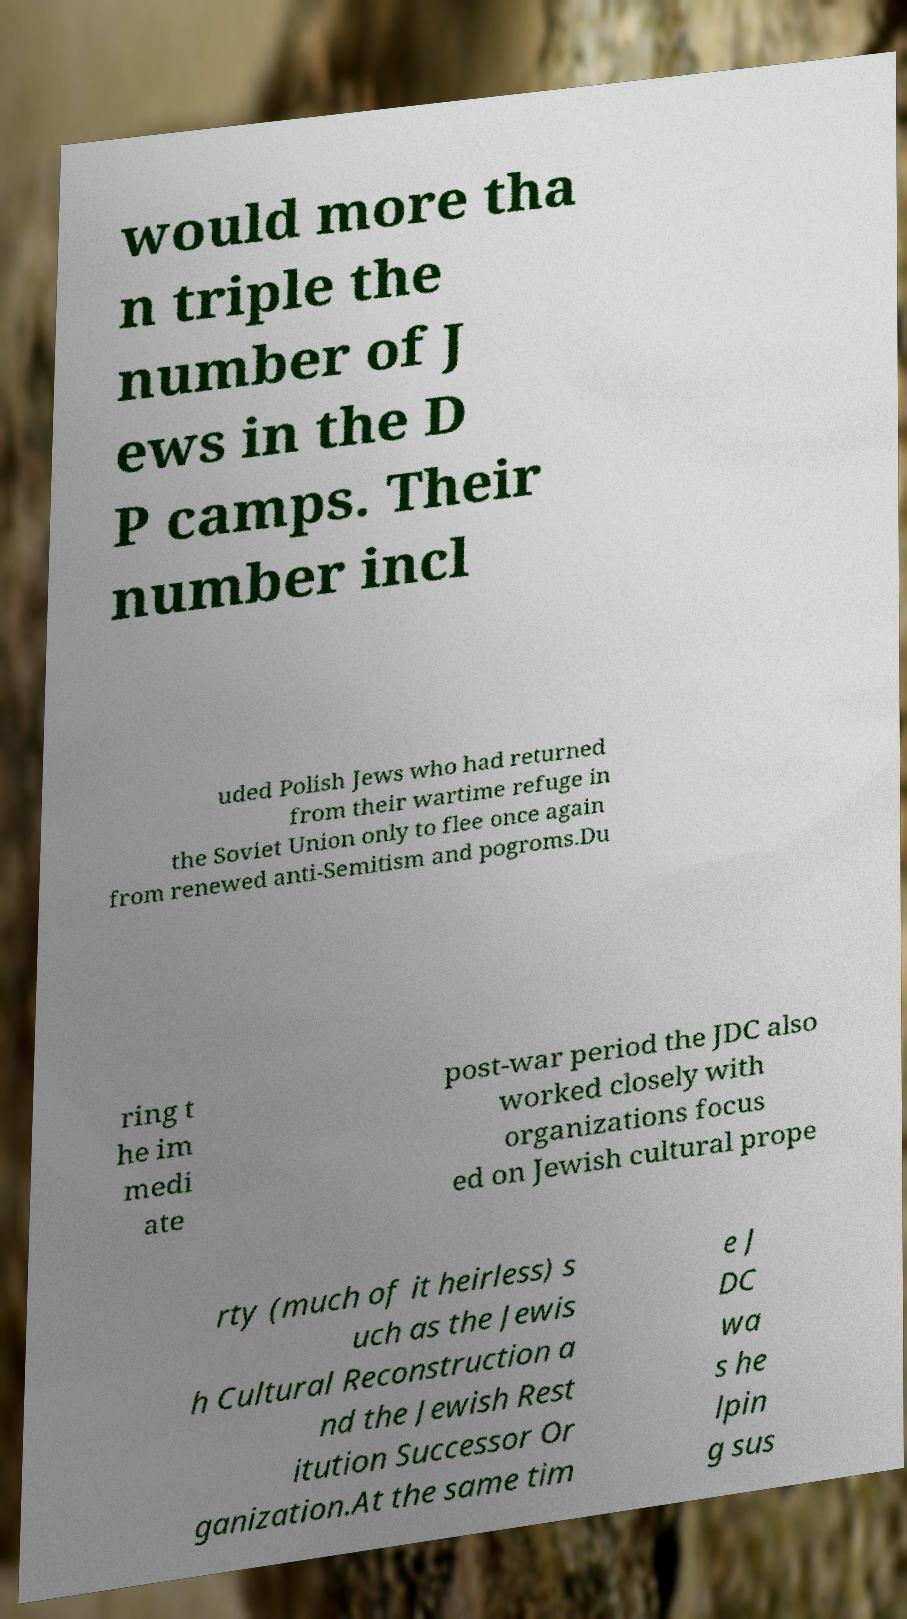Please read and relay the text visible in this image. What does it say? would more tha n triple the number of J ews in the D P camps. Their number incl uded Polish Jews who had returned from their wartime refuge in the Soviet Union only to flee once again from renewed anti-Semitism and pogroms.Du ring t he im medi ate post-war period the JDC also worked closely with organizations focus ed on Jewish cultural prope rty (much of it heirless) s uch as the Jewis h Cultural Reconstruction a nd the Jewish Rest itution Successor Or ganization.At the same tim e J DC wa s he lpin g sus 